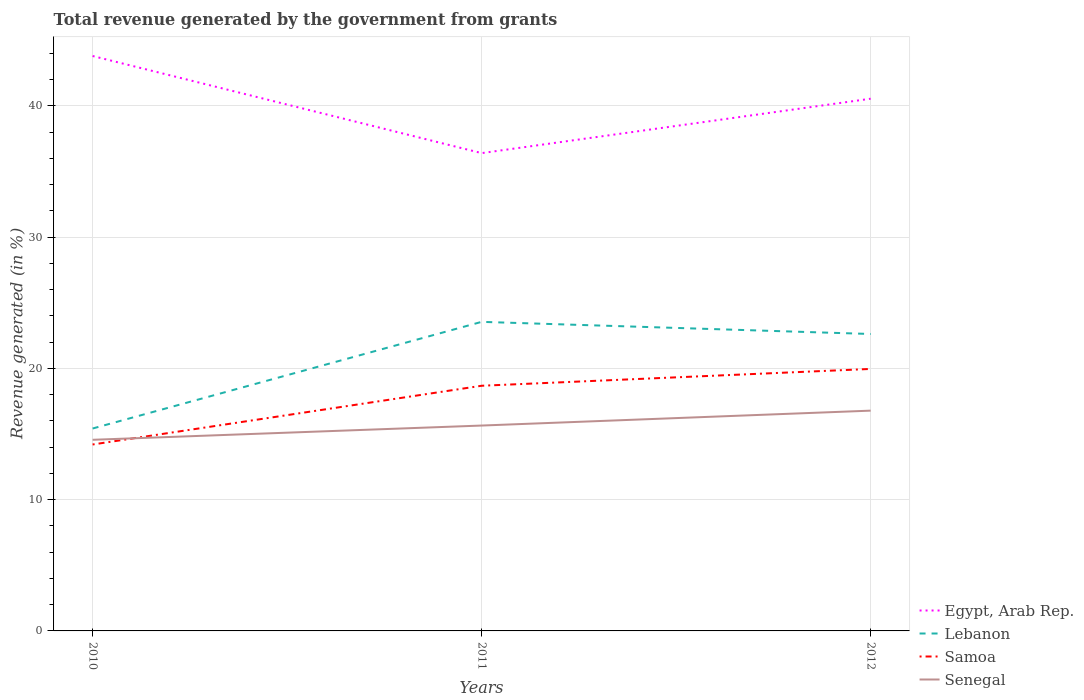Across all years, what is the maximum total revenue generated in Samoa?
Your response must be concise. 14.2. What is the total total revenue generated in Lebanon in the graph?
Provide a short and direct response. 0.92. What is the difference between the highest and the second highest total revenue generated in Lebanon?
Give a very brief answer. 8.13. Is the total revenue generated in Lebanon strictly greater than the total revenue generated in Samoa over the years?
Your answer should be compact. No. How many lines are there?
Offer a very short reply. 4. How many years are there in the graph?
Keep it short and to the point. 3. Does the graph contain any zero values?
Make the answer very short. No. How many legend labels are there?
Offer a terse response. 4. What is the title of the graph?
Provide a succinct answer. Total revenue generated by the government from grants. What is the label or title of the X-axis?
Make the answer very short. Years. What is the label or title of the Y-axis?
Offer a terse response. Revenue generated (in %). What is the Revenue generated (in %) in Egypt, Arab Rep. in 2010?
Offer a terse response. 43.8. What is the Revenue generated (in %) of Lebanon in 2010?
Your answer should be compact. 15.42. What is the Revenue generated (in %) in Samoa in 2010?
Provide a succinct answer. 14.2. What is the Revenue generated (in %) of Senegal in 2010?
Make the answer very short. 14.56. What is the Revenue generated (in %) of Egypt, Arab Rep. in 2011?
Offer a very short reply. 36.4. What is the Revenue generated (in %) in Lebanon in 2011?
Your answer should be compact. 23.55. What is the Revenue generated (in %) in Samoa in 2011?
Your answer should be compact. 18.68. What is the Revenue generated (in %) of Senegal in 2011?
Make the answer very short. 15.65. What is the Revenue generated (in %) in Egypt, Arab Rep. in 2012?
Make the answer very short. 40.55. What is the Revenue generated (in %) of Lebanon in 2012?
Ensure brevity in your answer.  22.62. What is the Revenue generated (in %) of Samoa in 2012?
Offer a terse response. 19.96. What is the Revenue generated (in %) in Senegal in 2012?
Make the answer very short. 16.78. Across all years, what is the maximum Revenue generated (in %) in Egypt, Arab Rep.?
Keep it short and to the point. 43.8. Across all years, what is the maximum Revenue generated (in %) in Lebanon?
Make the answer very short. 23.55. Across all years, what is the maximum Revenue generated (in %) in Samoa?
Your response must be concise. 19.96. Across all years, what is the maximum Revenue generated (in %) in Senegal?
Give a very brief answer. 16.78. Across all years, what is the minimum Revenue generated (in %) of Egypt, Arab Rep.?
Provide a succinct answer. 36.4. Across all years, what is the minimum Revenue generated (in %) of Lebanon?
Provide a succinct answer. 15.42. Across all years, what is the minimum Revenue generated (in %) in Samoa?
Offer a terse response. 14.2. Across all years, what is the minimum Revenue generated (in %) of Senegal?
Your answer should be compact. 14.56. What is the total Revenue generated (in %) of Egypt, Arab Rep. in the graph?
Keep it short and to the point. 120.75. What is the total Revenue generated (in %) of Lebanon in the graph?
Make the answer very short. 61.59. What is the total Revenue generated (in %) of Samoa in the graph?
Offer a terse response. 52.84. What is the total Revenue generated (in %) of Senegal in the graph?
Offer a terse response. 46.99. What is the difference between the Revenue generated (in %) in Egypt, Arab Rep. in 2010 and that in 2011?
Your response must be concise. 7.4. What is the difference between the Revenue generated (in %) of Lebanon in 2010 and that in 2011?
Keep it short and to the point. -8.13. What is the difference between the Revenue generated (in %) of Samoa in 2010 and that in 2011?
Give a very brief answer. -4.47. What is the difference between the Revenue generated (in %) in Senegal in 2010 and that in 2011?
Ensure brevity in your answer.  -1.08. What is the difference between the Revenue generated (in %) of Egypt, Arab Rep. in 2010 and that in 2012?
Offer a terse response. 3.25. What is the difference between the Revenue generated (in %) of Lebanon in 2010 and that in 2012?
Your answer should be compact. -7.2. What is the difference between the Revenue generated (in %) of Samoa in 2010 and that in 2012?
Your answer should be very brief. -5.76. What is the difference between the Revenue generated (in %) of Senegal in 2010 and that in 2012?
Provide a short and direct response. -2.22. What is the difference between the Revenue generated (in %) of Egypt, Arab Rep. in 2011 and that in 2012?
Keep it short and to the point. -4.15. What is the difference between the Revenue generated (in %) in Lebanon in 2011 and that in 2012?
Provide a short and direct response. 0.92. What is the difference between the Revenue generated (in %) of Samoa in 2011 and that in 2012?
Your response must be concise. -1.28. What is the difference between the Revenue generated (in %) of Senegal in 2011 and that in 2012?
Your answer should be compact. -1.14. What is the difference between the Revenue generated (in %) in Egypt, Arab Rep. in 2010 and the Revenue generated (in %) in Lebanon in 2011?
Make the answer very short. 20.25. What is the difference between the Revenue generated (in %) in Egypt, Arab Rep. in 2010 and the Revenue generated (in %) in Samoa in 2011?
Keep it short and to the point. 25.12. What is the difference between the Revenue generated (in %) in Egypt, Arab Rep. in 2010 and the Revenue generated (in %) in Senegal in 2011?
Your response must be concise. 28.15. What is the difference between the Revenue generated (in %) in Lebanon in 2010 and the Revenue generated (in %) in Samoa in 2011?
Offer a very short reply. -3.26. What is the difference between the Revenue generated (in %) of Lebanon in 2010 and the Revenue generated (in %) of Senegal in 2011?
Ensure brevity in your answer.  -0.23. What is the difference between the Revenue generated (in %) in Samoa in 2010 and the Revenue generated (in %) in Senegal in 2011?
Offer a very short reply. -1.44. What is the difference between the Revenue generated (in %) of Egypt, Arab Rep. in 2010 and the Revenue generated (in %) of Lebanon in 2012?
Ensure brevity in your answer.  21.18. What is the difference between the Revenue generated (in %) in Egypt, Arab Rep. in 2010 and the Revenue generated (in %) in Samoa in 2012?
Provide a short and direct response. 23.84. What is the difference between the Revenue generated (in %) in Egypt, Arab Rep. in 2010 and the Revenue generated (in %) in Senegal in 2012?
Your answer should be very brief. 27.02. What is the difference between the Revenue generated (in %) in Lebanon in 2010 and the Revenue generated (in %) in Samoa in 2012?
Keep it short and to the point. -4.54. What is the difference between the Revenue generated (in %) in Lebanon in 2010 and the Revenue generated (in %) in Senegal in 2012?
Provide a succinct answer. -1.36. What is the difference between the Revenue generated (in %) in Samoa in 2010 and the Revenue generated (in %) in Senegal in 2012?
Your response must be concise. -2.58. What is the difference between the Revenue generated (in %) of Egypt, Arab Rep. in 2011 and the Revenue generated (in %) of Lebanon in 2012?
Your response must be concise. 13.78. What is the difference between the Revenue generated (in %) of Egypt, Arab Rep. in 2011 and the Revenue generated (in %) of Samoa in 2012?
Your answer should be very brief. 16.44. What is the difference between the Revenue generated (in %) of Egypt, Arab Rep. in 2011 and the Revenue generated (in %) of Senegal in 2012?
Give a very brief answer. 19.62. What is the difference between the Revenue generated (in %) in Lebanon in 2011 and the Revenue generated (in %) in Samoa in 2012?
Provide a short and direct response. 3.59. What is the difference between the Revenue generated (in %) in Lebanon in 2011 and the Revenue generated (in %) in Senegal in 2012?
Make the answer very short. 6.76. What is the difference between the Revenue generated (in %) in Samoa in 2011 and the Revenue generated (in %) in Senegal in 2012?
Provide a short and direct response. 1.9. What is the average Revenue generated (in %) of Egypt, Arab Rep. per year?
Your answer should be compact. 40.25. What is the average Revenue generated (in %) in Lebanon per year?
Give a very brief answer. 20.53. What is the average Revenue generated (in %) in Samoa per year?
Make the answer very short. 17.61. What is the average Revenue generated (in %) in Senegal per year?
Provide a succinct answer. 15.66. In the year 2010, what is the difference between the Revenue generated (in %) in Egypt, Arab Rep. and Revenue generated (in %) in Lebanon?
Ensure brevity in your answer.  28.38. In the year 2010, what is the difference between the Revenue generated (in %) in Egypt, Arab Rep. and Revenue generated (in %) in Samoa?
Offer a very short reply. 29.6. In the year 2010, what is the difference between the Revenue generated (in %) of Egypt, Arab Rep. and Revenue generated (in %) of Senegal?
Your answer should be compact. 29.24. In the year 2010, what is the difference between the Revenue generated (in %) of Lebanon and Revenue generated (in %) of Samoa?
Offer a terse response. 1.22. In the year 2010, what is the difference between the Revenue generated (in %) of Lebanon and Revenue generated (in %) of Senegal?
Keep it short and to the point. 0.86. In the year 2010, what is the difference between the Revenue generated (in %) of Samoa and Revenue generated (in %) of Senegal?
Make the answer very short. -0.36. In the year 2011, what is the difference between the Revenue generated (in %) of Egypt, Arab Rep. and Revenue generated (in %) of Lebanon?
Your answer should be very brief. 12.86. In the year 2011, what is the difference between the Revenue generated (in %) in Egypt, Arab Rep. and Revenue generated (in %) in Samoa?
Your answer should be compact. 17.72. In the year 2011, what is the difference between the Revenue generated (in %) of Egypt, Arab Rep. and Revenue generated (in %) of Senegal?
Keep it short and to the point. 20.76. In the year 2011, what is the difference between the Revenue generated (in %) in Lebanon and Revenue generated (in %) in Samoa?
Your response must be concise. 4.87. In the year 2011, what is the difference between the Revenue generated (in %) in Lebanon and Revenue generated (in %) in Senegal?
Provide a short and direct response. 7.9. In the year 2011, what is the difference between the Revenue generated (in %) of Samoa and Revenue generated (in %) of Senegal?
Make the answer very short. 3.03. In the year 2012, what is the difference between the Revenue generated (in %) in Egypt, Arab Rep. and Revenue generated (in %) in Lebanon?
Provide a succinct answer. 17.93. In the year 2012, what is the difference between the Revenue generated (in %) of Egypt, Arab Rep. and Revenue generated (in %) of Samoa?
Provide a short and direct response. 20.59. In the year 2012, what is the difference between the Revenue generated (in %) of Egypt, Arab Rep. and Revenue generated (in %) of Senegal?
Provide a succinct answer. 23.76. In the year 2012, what is the difference between the Revenue generated (in %) in Lebanon and Revenue generated (in %) in Samoa?
Give a very brief answer. 2.66. In the year 2012, what is the difference between the Revenue generated (in %) in Lebanon and Revenue generated (in %) in Senegal?
Provide a succinct answer. 5.84. In the year 2012, what is the difference between the Revenue generated (in %) of Samoa and Revenue generated (in %) of Senegal?
Your response must be concise. 3.18. What is the ratio of the Revenue generated (in %) in Egypt, Arab Rep. in 2010 to that in 2011?
Your answer should be very brief. 1.2. What is the ratio of the Revenue generated (in %) of Lebanon in 2010 to that in 2011?
Offer a terse response. 0.65. What is the ratio of the Revenue generated (in %) of Samoa in 2010 to that in 2011?
Offer a very short reply. 0.76. What is the ratio of the Revenue generated (in %) of Senegal in 2010 to that in 2011?
Make the answer very short. 0.93. What is the ratio of the Revenue generated (in %) in Egypt, Arab Rep. in 2010 to that in 2012?
Offer a terse response. 1.08. What is the ratio of the Revenue generated (in %) in Lebanon in 2010 to that in 2012?
Keep it short and to the point. 0.68. What is the ratio of the Revenue generated (in %) of Samoa in 2010 to that in 2012?
Ensure brevity in your answer.  0.71. What is the ratio of the Revenue generated (in %) of Senegal in 2010 to that in 2012?
Make the answer very short. 0.87. What is the ratio of the Revenue generated (in %) of Egypt, Arab Rep. in 2011 to that in 2012?
Your answer should be compact. 0.9. What is the ratio of the Revenue generated (in %) of Lebanon in 2011 to that in 2012?
Ensure brevity in your answer.  1.04. What is the ratio of the Revenue generated (in %) in Samoa in 2011 to that in 2012?
Offer a very short reply. 0.94. What is the ratio of the Revenue generated (in %) of Senegal in 2011 to that in 2012?
Offer a very short reply. 0.93. What is the difference between the highest and the second highest Revenue generated (in %) in Egypt, Arab Rep.?
Provide a short and direct response. 3.25. What is the difference between the highest and the second highest Revenue generated (in %) of Lebanon?
Offer a terse response. 0.92. What is the difference between the highest and the second highest Revenue generated (in %) in Samoa?
Make the answer very short. 1.28. What is the difference between the highest and the second highest Revenue generated (in %) in Senegal?
Make the answer very short. 1.14. What is the difference between the highest and the lowest Revenue generated (in %) in Egypt, Arab Rep.?
Your answer should be very brief. 7.4. What is the difference between the highest and the lowest Revenue generated (in %) of Lebanon?
Make the answer very short. 8.13. What is the difference between the highest and the lowest Revenue generated (in %) of Samoa?
Offer a terse response. 5.76. What is the difference between the highest and the lowest Revenue generated (in %) of Senegal?
Provide a succinct answer. 2.22. 